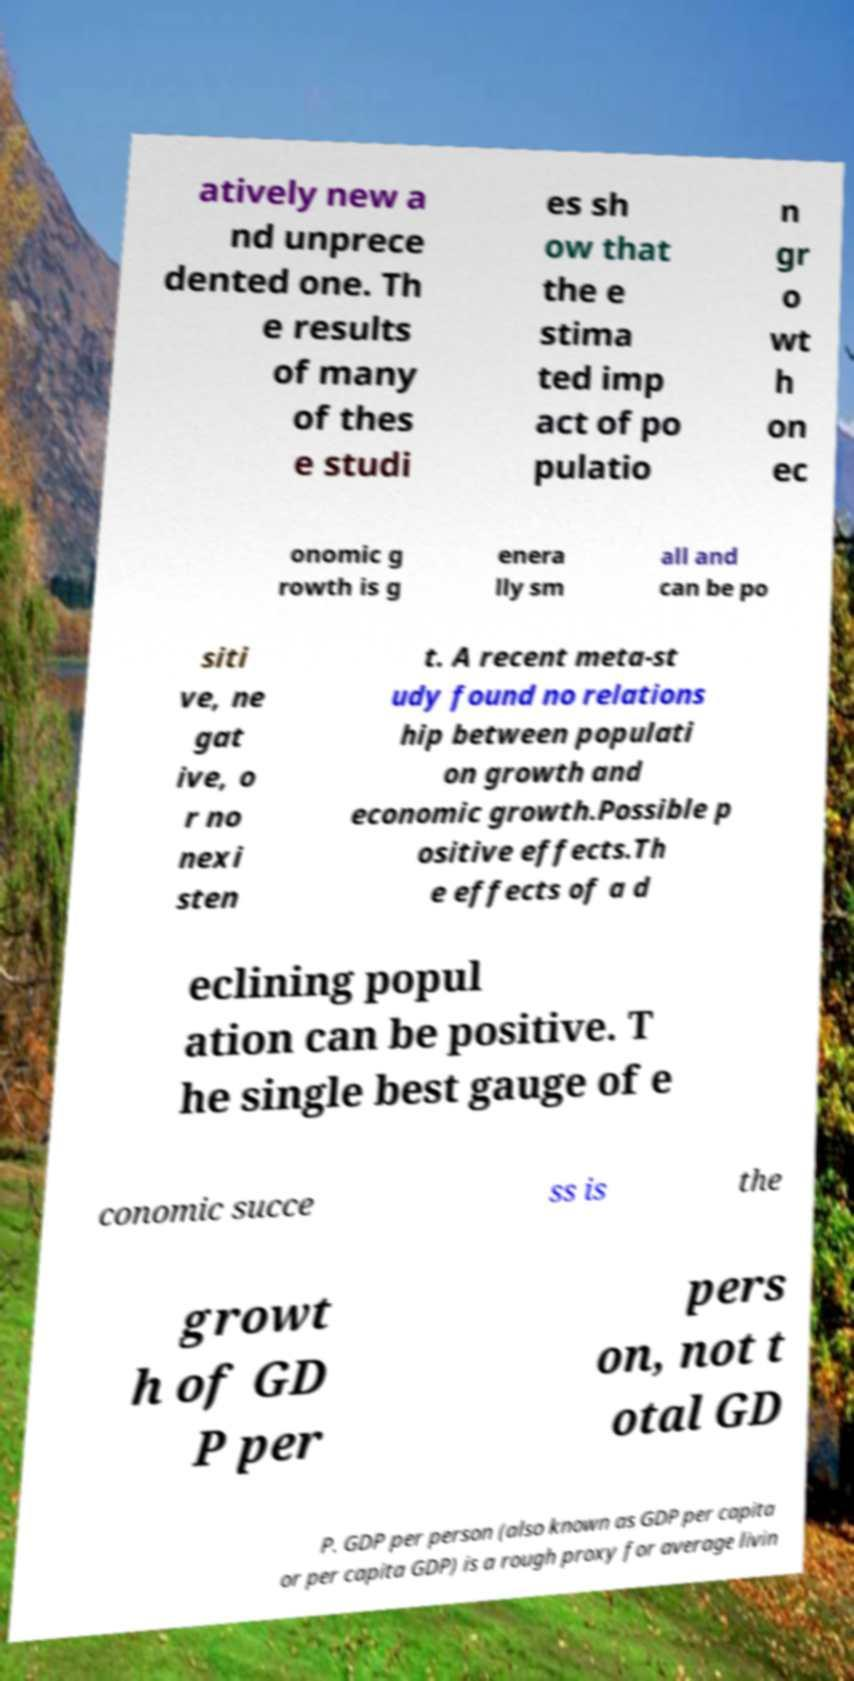Could you assist in decoding the text presented in this image and type it out clearly? atively new a nd unprece dented one. Th e results of many of thes e studi es sh ow that the e stima ted imp act of po pulatio n gr o wt h on ec onomic g rowth is g enera lly sm all and can be po siti ve, ne gat ive, o r no nexi sten t. A recent meta-st udy found no relations hip between populati on growth and economic growth.Possible p ositive effects.Th e effects of a d eclining popul ation can be positive. T he single best gauge of e conomic succe ss is the growt h of GD P per pers on, not t otal GD P. GDP per person (also known as GDP per capita or per capita GDP) is a rough proxy for average livin 